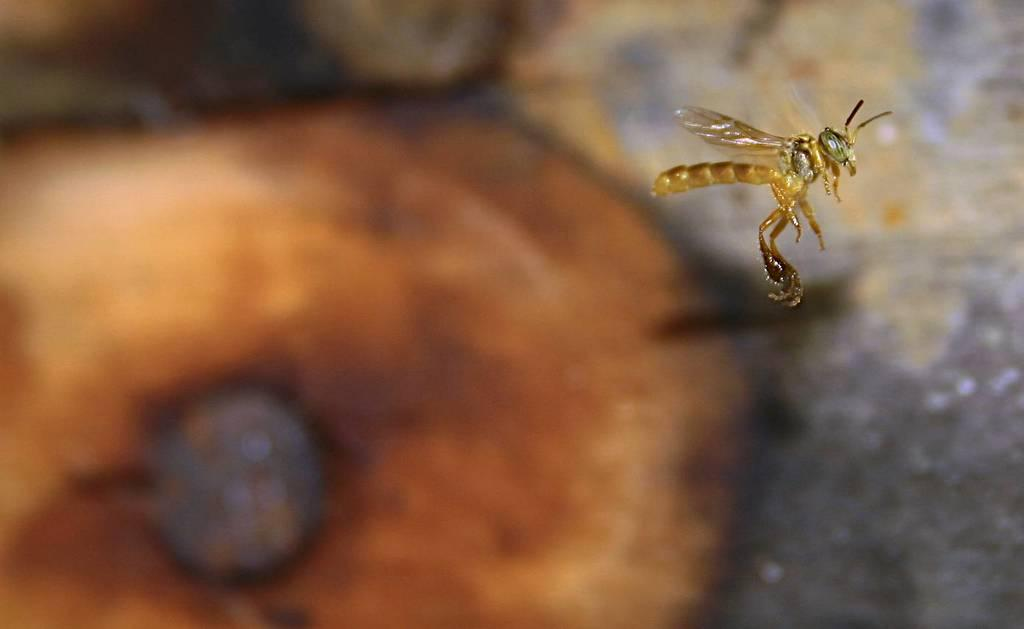What type of creature is present in the image? There is an insect in the image. Where is the insect located in the image? The insect is in the front of the image. What can be observed about the background of the image? The background of the image is blurry. What type of fuel is the insect using to fly in the image? Insects do not use fuel to fly; they have wings and use their muscles to generate lift and propel themselves through the air. How many lines can be seen in the image? There is no mention of lines in the provided facts, so it is not possible to determine the number of lines in the image. 